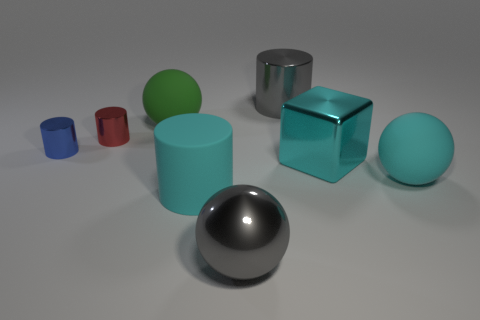Are the small blue cylinder and the cyan cylinder made of the same material?
Offer a very short reply. No. Is the color of the metal sphere the same as the big metal cylinder?
Your answer should be compact. Yes. Are there fewer big cyan shiny blocks than brown matte cylinders?
Your answer should be compact. No. The big metal object behind the tiny blue shiny cylinder in front of the large green ball is what color?
Give a very brief answer. Gray. What is the material of the cyan object that is the same shape as the small blue object?
Make the answer very short. Rubber. How many rubber things are small brown blocks or big cubes?
Offer a terse response. 0. Do the gray thing in front of the red thing and the large cylinder that is left of the big gray cylinder have the same material?
Offer a terse response. No. Are any small things visible?
Offer a terse response. Yes. There is a cyan rubber thing that is to the right of the cube; is it the same shape as the large matte object that is behind the red metallic thing?
Your answer should be compact. Yes. Are there any other big cyan cylinders that have the same material as the large cyan cylinder?
Make the answer very short. No. 